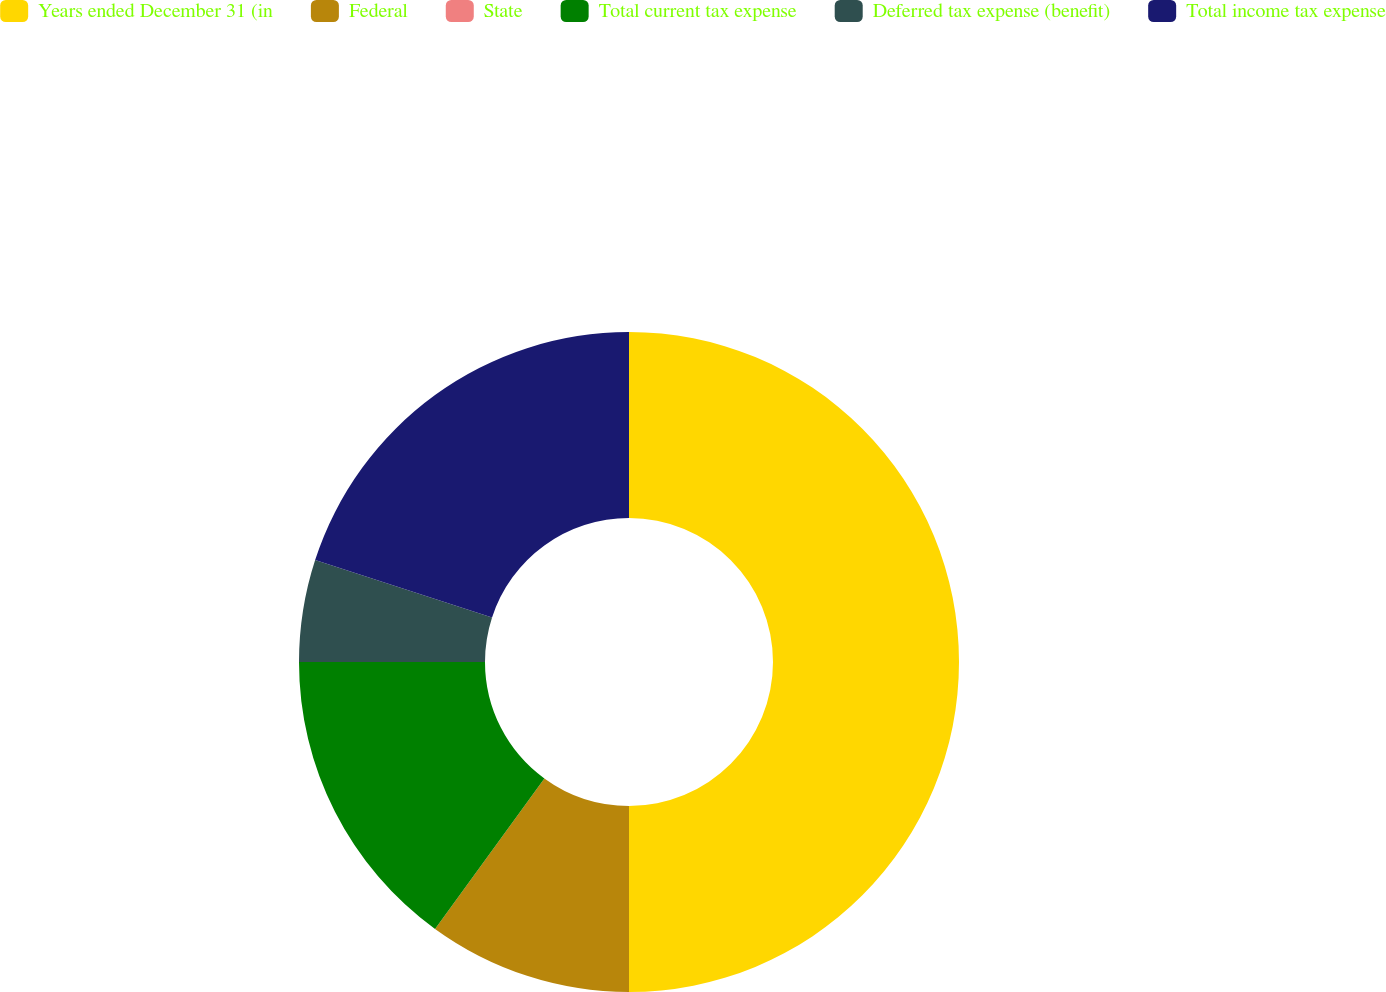<chart> <loc_0><loc_0><loc_500><loc_500><pie_chart><fcel>Years ended December 31 (in<fcel>Federal<fcel>State<fcel>Total current tax expense<fcel>Deferred tax expense (benefit)<fcel>Total income tax expense<nl><fcel>50.0%<fcel>10.0%<fcel>0.0%<fcel>15.0%<fcel>5.0%<fcel>20.0%<nl></chart> 